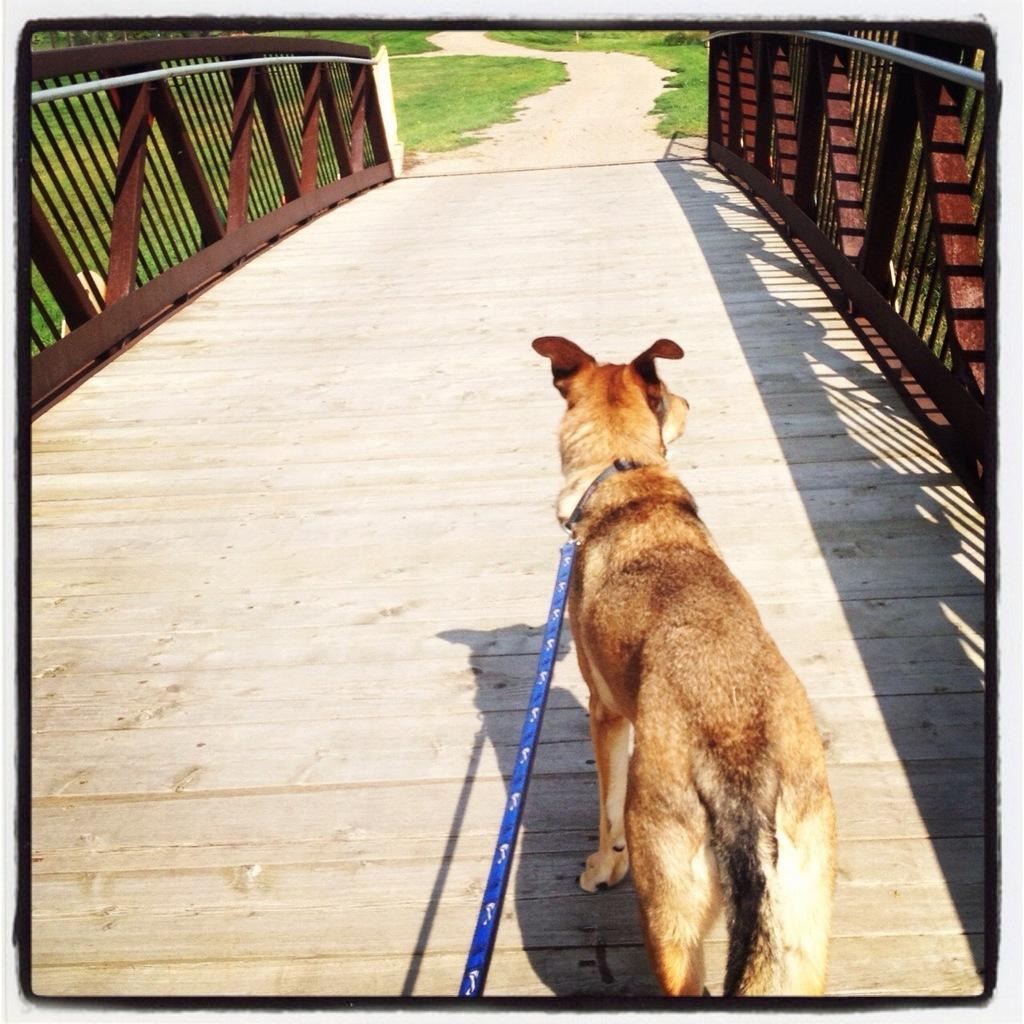Can you describe this image briefly? In this image we can see a dog with a leash on the wooden surface. We can also see the railing, pathway and grass. 